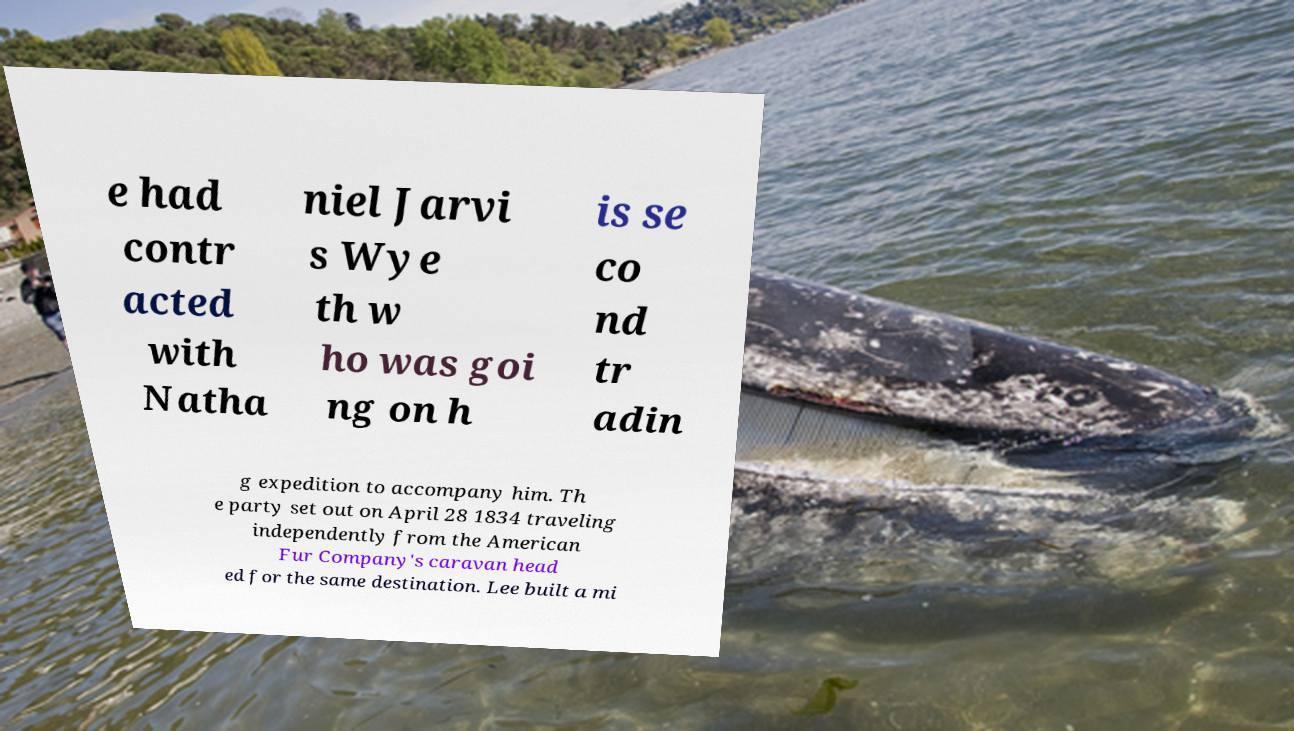I need the written content from this picture converted into text. Can you do that? e had contr acted with Natha niel Jarvi s Wye th w ho was goi ng on h is se co nd tr adin g expedition to accompany him. Th e party set out on April 28 1834 traveling independently from the American Fur Company's caravan head ed for the same destination. Lee built a mi 